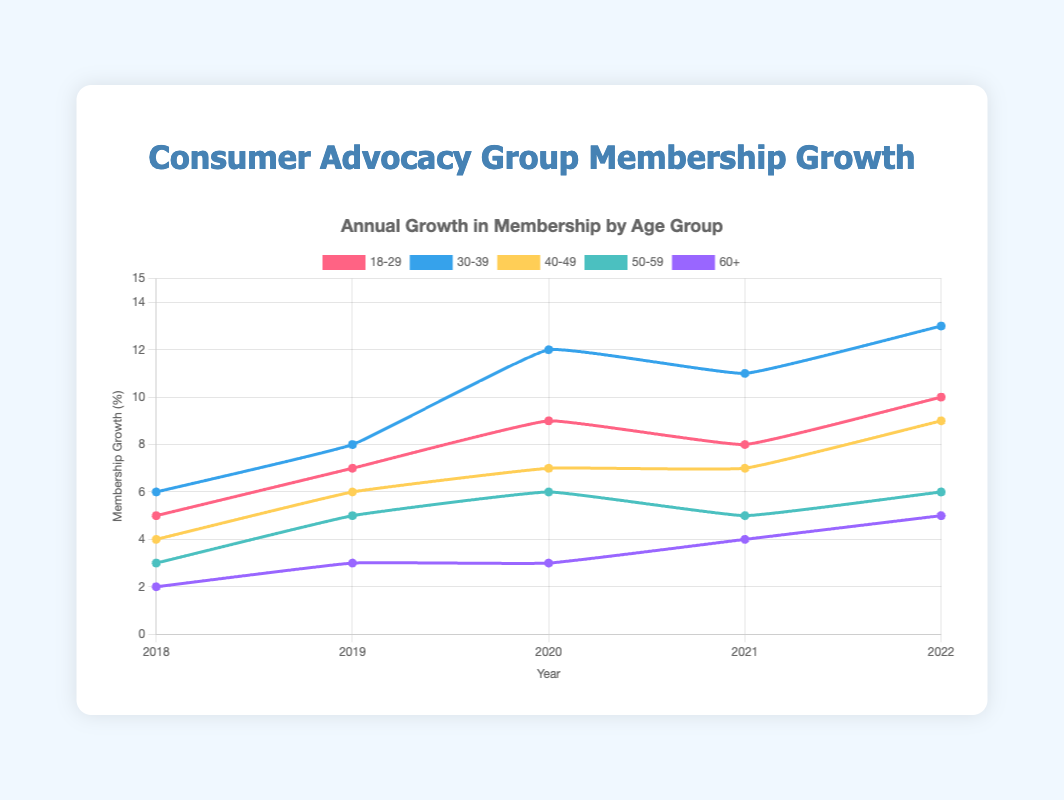Which age group had the highest membership growth in 2022? The age group with the highest membership growth in 2022 can be identified by looking at the highest point among the lines on the graph at the year 2022. For 2022, the 30-39 age group shows the highest value at 13%.
Answer: 30-39 Which year had the lowest membership growth for the 50-59 age group? To determine the lowest membership growth for the 50-59 age group, look along the 50-59 line and find the year with the lowest value. The 50-59 line hits its lowest point in 2018 at 3%.
Answer: 2018 Compare the membership growth trends between the 18-29 and 60+ age groups. Comparing the 18-29 and 60+ lines, the 18-29 group has a generally upward trend, starting at 5% in 2018 and ending at 10% in 2022. The 60+ group also shows an upward trend but at a lower magnitude, starting at 2% in 2018 and ending at 5% in 2022.
Answer: Both upward Which age group showed the most consistent growth over the years? Consistent growth can be assessed by observing the smoothness and steady rise of the line. The 30-39 age group shows a generally steady increase each year, suggesting consistent growth.
Answer: 30-39 What was the membership growth for the 40-49 age group in 2020? By locating the 40-49 line and tracing it to the year 2020, the value for membership growth in 2020 is 7%.
Answer: 7% How much did the membership growth for the age group 18-29 change from 2021 to 2022? To find the change, subtract the 2021 value from the 2022 value for the 18-29 age group. For 18-29, the change is 10% - 8% = 2%.
Answer: 2% What is the combined membership growth for the 40-49 and 50-59 age groups in 2021? Adding the membership growth of the 40-49 age group (7%) and the 50-59 age group (5%) in 2021 gives a total of 7% + 5% = 12%.
Answer: 12% Which color represents the 60+ age group line on the plot? The color of the line for each age group is specified. The 60+ age group is represented by the color purple on the plot.
Answer: purple What is the average membership growth of the 30-39 age group over the 5 years? To find the average, sum up the membership growth values for the 30-39 age group and divide by 5: 
(6% + 8% + 12% + 11% + 13%) / 5 = 50% / 5 = 10%.
Answer: 10% 